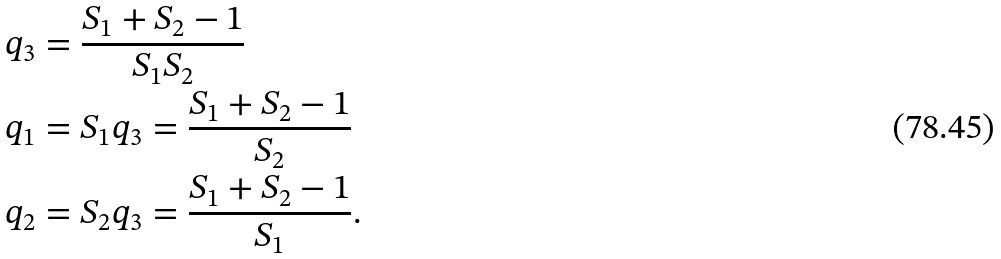Convert formula to latex. <formula><loc_0><loc_0><loc_500><loc_500>q _ { 3 } & = \frac { S _ { 1 } + S _ { 2 } - 1 } { S _ { 1 } S _ { 2 } } \\ q _ { 1 } & = S _ { 1 } q _ { 3 } = \frac { S _ { 1 } + S _ { 2 } - 1 } { S _ { 2 } } \\ q _ { 2 } & = S _ { 2 } q _ { 3 } = \frac { S _ { 1 } + S _ { 2 } - 1 } { S _ { 1 } } .</formula> 